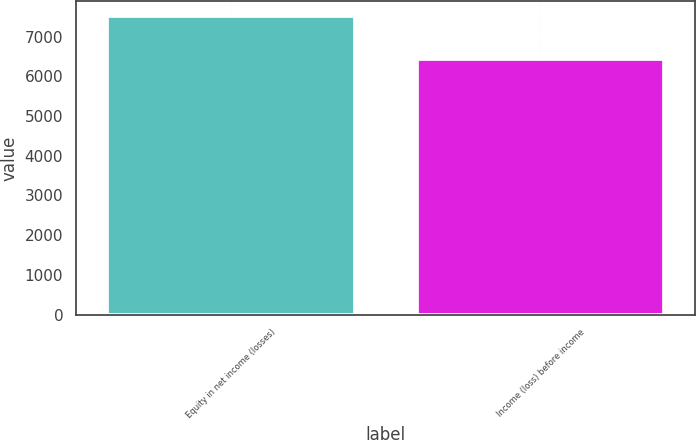Convert chart to OTSL. <chart><loc_0><loc_0><loc_500><loc_500><bar_chart><fcel>Equity in net income (losses)<fcel>Income (loss) before income<nl><fcel>7509<fcel>6443<nl></chart> 